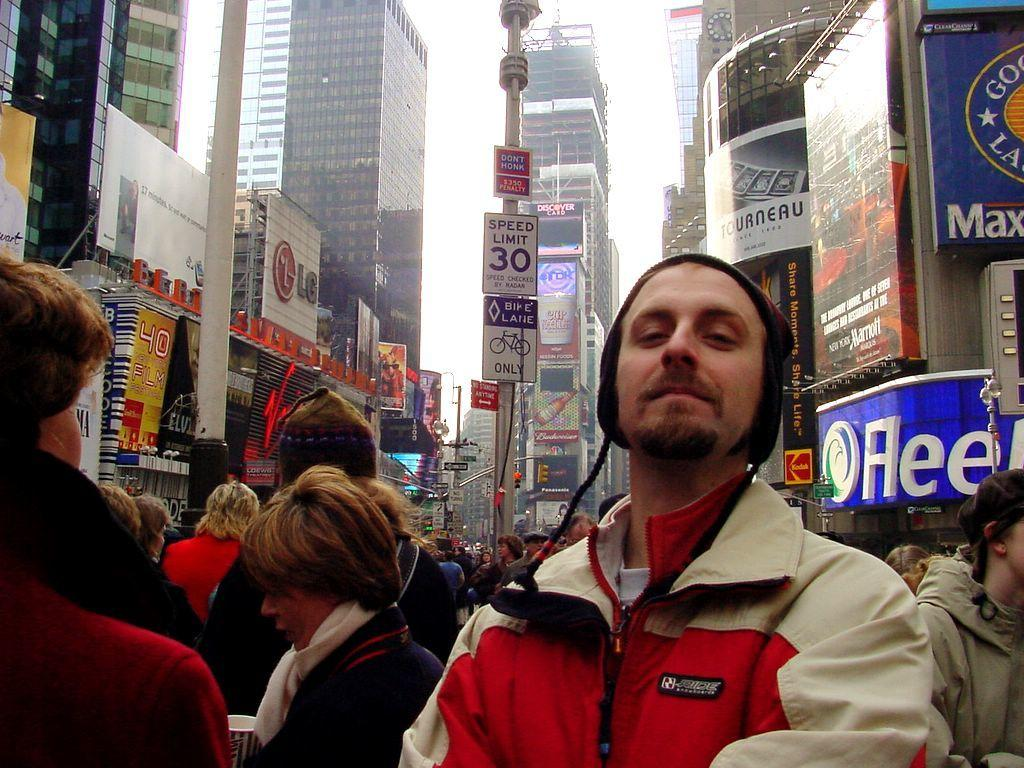Provide a one-sentence caption for the provided image. Man posing for a photo in front of a side which says the Speed limit is 30. 